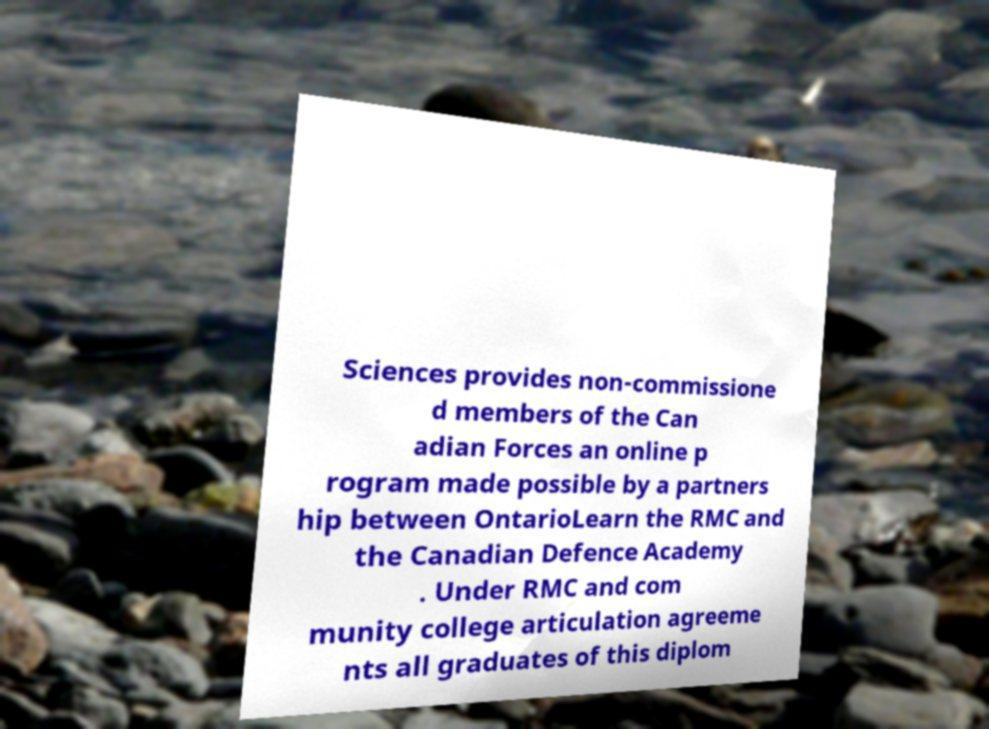Can you accurately transcribe the text from the provided image for me? Sciences provides non-commissione d members of the Can adian Forces an online p rogram made possible by a partners hip between OntarioLearn the RMC and the Canadian Defence Academy . Under RMC and com munity college articulation agreeme nts all graduates of this diplom 